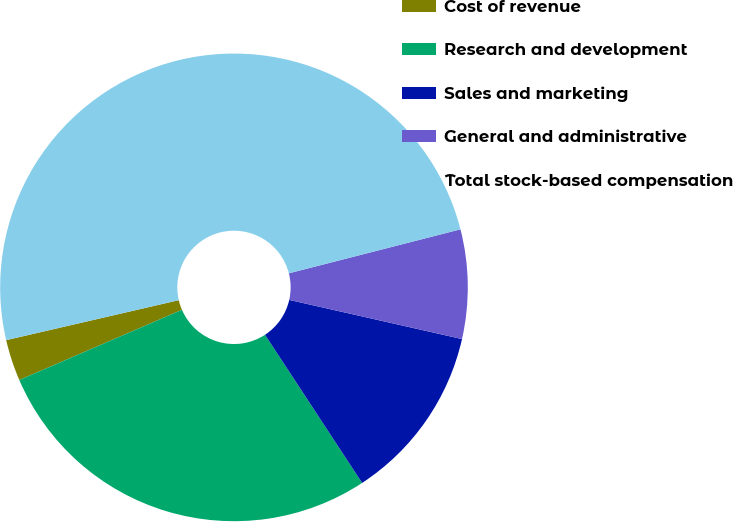Convert chart to OTSL. <chart><loc_0><loc_0><loc_500><loc_500><pie_chart><fcel>Cost of revenue<fcel>Research and development<fcel>Sales and marketing<fcel>General and administrative<fcel>Total stock-based compensation<nl><fcel>2.86%<fcel>27.75%<fcel>12.22%<fcel>7.54%<fcel>49.63%<nl></chart> 